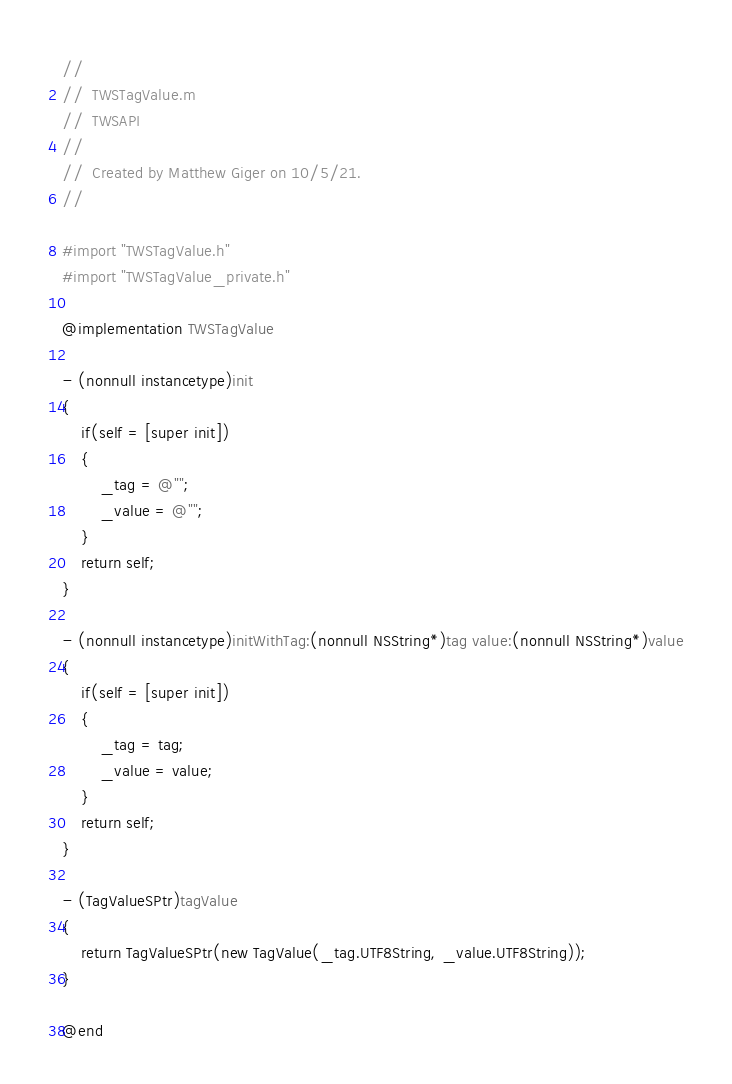<code> <loc_0><loc_0><loc_500><loc_500><_ObjectiveC_>//
//  TWSTagValue.m
//  TWSAPI
//
//  Created by Matthew Giger on 10/5/21.
//

#import "TWSTagValue.h"
#import "TWSTagValue_private.h"

@implementation TWSTagValue

- (nonnull instancetype)init
{
	if(self = [super init])
	{
		_tag = @"";
		_value = @"";
	}
	return self;
}

- (nonnull instancetype)initWithTag:(nonnull NSString*)tag value:(nonnull NSString*)value
{
	if(self = [super init])
	{
		_tag = tag;
		_value = value;
	}
	return self;
}

- (TagValueSPtr)tagValue
{
	return TagValueSPtr(new TagValue(_tag.UTF8String, _value.UTF8String));
}

@end
</code> 